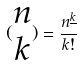Convert formula to latex. <formula><loc_0><loc_0><loc_500><loc_500>( \begin{matrix} n \\ k \end{matrix} ) = \frac { n ^ { \underline { k } } } { k ! }</formula> 